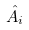Convert formula to latex. <formula><loc_0><loc_0><loc_500><loc_500>\hat { A } _ { i }</formula> 